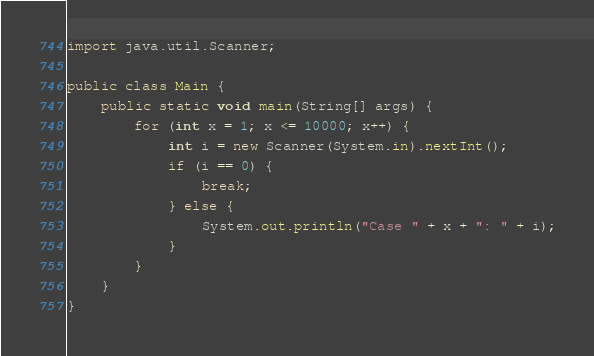<code> <loc_0><loc_0><loc_500><loc_500><_Java_>import java.util.Scanner;

public class Main {
    public static void main(String[] args) {
        for (int x = 1; x <= 10000; x++) {
            int i = new Scanner(System.in).nextInt();
            if (i == 0) {
                break;
            } else {
                System.out.println("Case " + x + ": " + i);
            }
        }
    }
}

</code> 